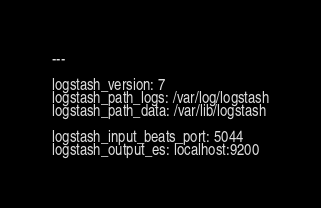<code> <loc_0><loc_0><loc_500><loc_500><_YAML_>---

logstash_version: 7
logstash_path_logs: /var/log/logstash
logstash_path_data: /var/lib/logstash

logstash_input_beats_port: 5044
logstash_output_es: localhost:9200
</code> 